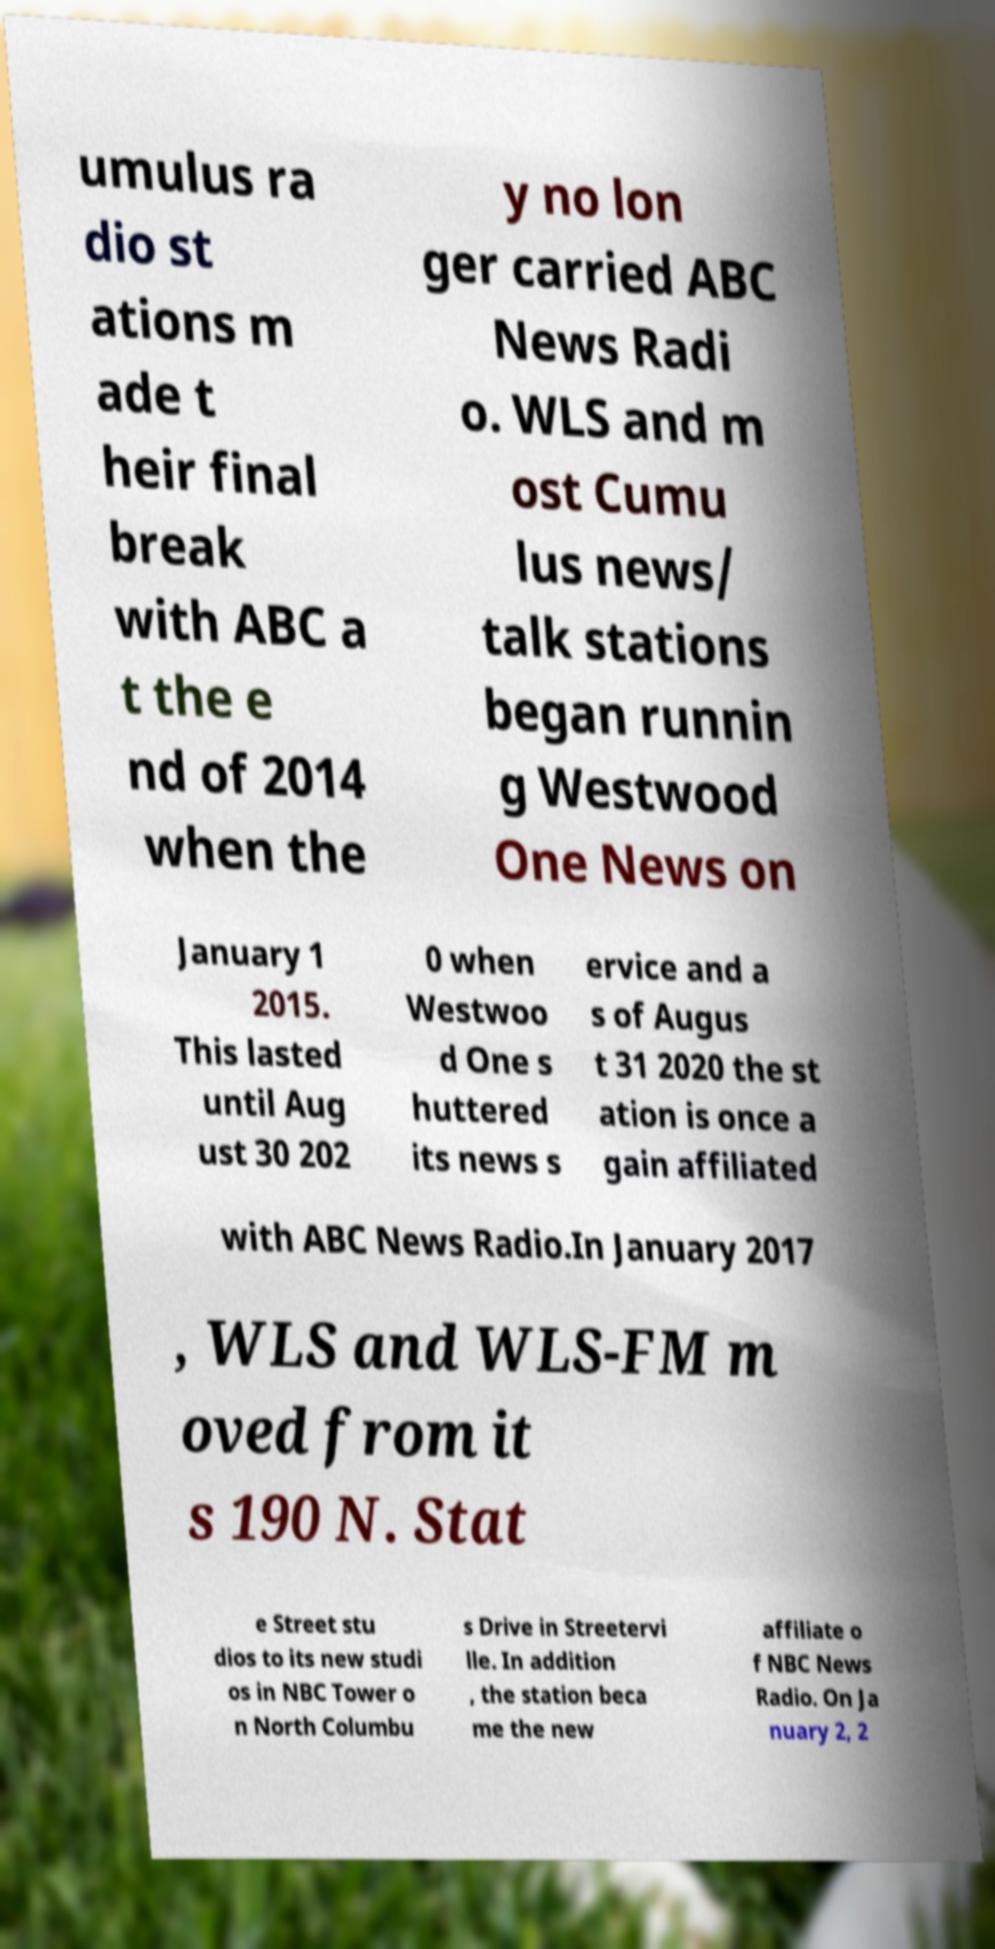There's text embedded in this image that I need extracted. Can you transcribe it verbatim? umulus ra dio st ations m ade t heir final break with ABC a t the e nd of 2014 when the y no lon ger carried ABC News Radi o. WLS and m ost Cumu lus news/ talk stations began runnin g Westwood One News on January 1 2015. This lasted until Aug ust 30 202 0 when Westwoo d One s huttered its news s ervice and a s of Augus t 31 2020 the st ation is once a gain affiliated with ABC News Radio.In January 2017 , WLS and WLS-FM m oved from it s 190 N. Stat e Street stu dios to its new studi os in NBC Tower o n North Columbu s Drive in Streetervi lle. In addition , the station beca me the new affiliate o f NBC News Radio. On Ja nuary 2, 2 